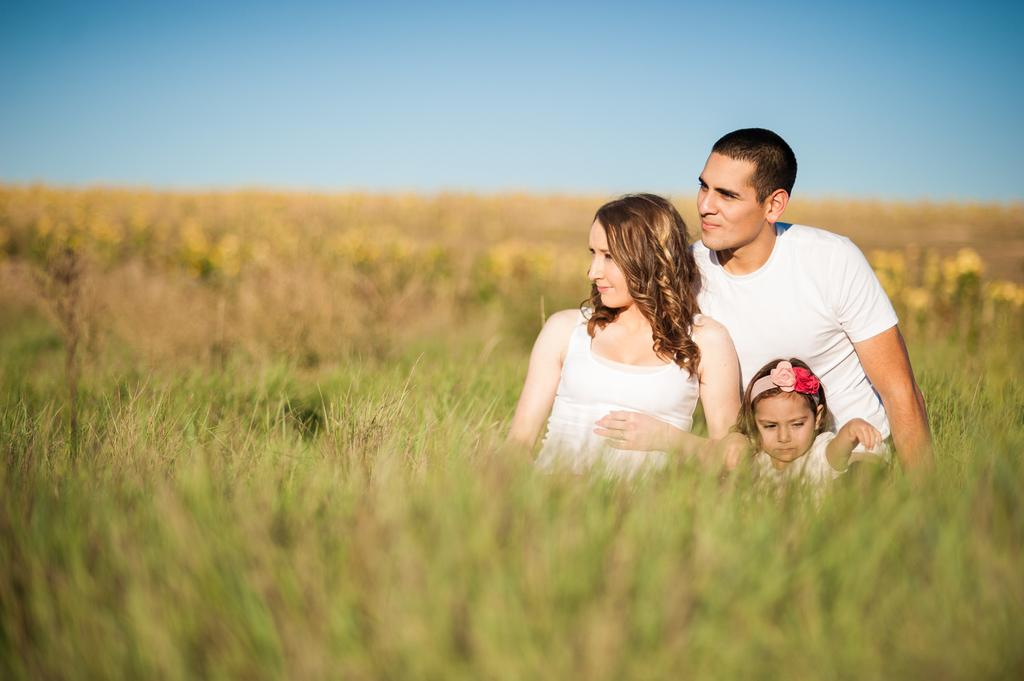How many people are in the image? There are three people in the image: a woman, a man, and a kid. What are they doing in the image? They are on the ground. What is the ground covered with? The ground is covered with grass. What can be seen in the background of the image? There is sky visible in the background of the image. What type of dirt can be seen on the kid's clothes in the image? There is no dirt visible on the kid's clothes in the image. What is the reaction of the woman when she sees the man's new hairstyle in the image? There is no information about the man's hairstyle or the woman's reaction in the image. 